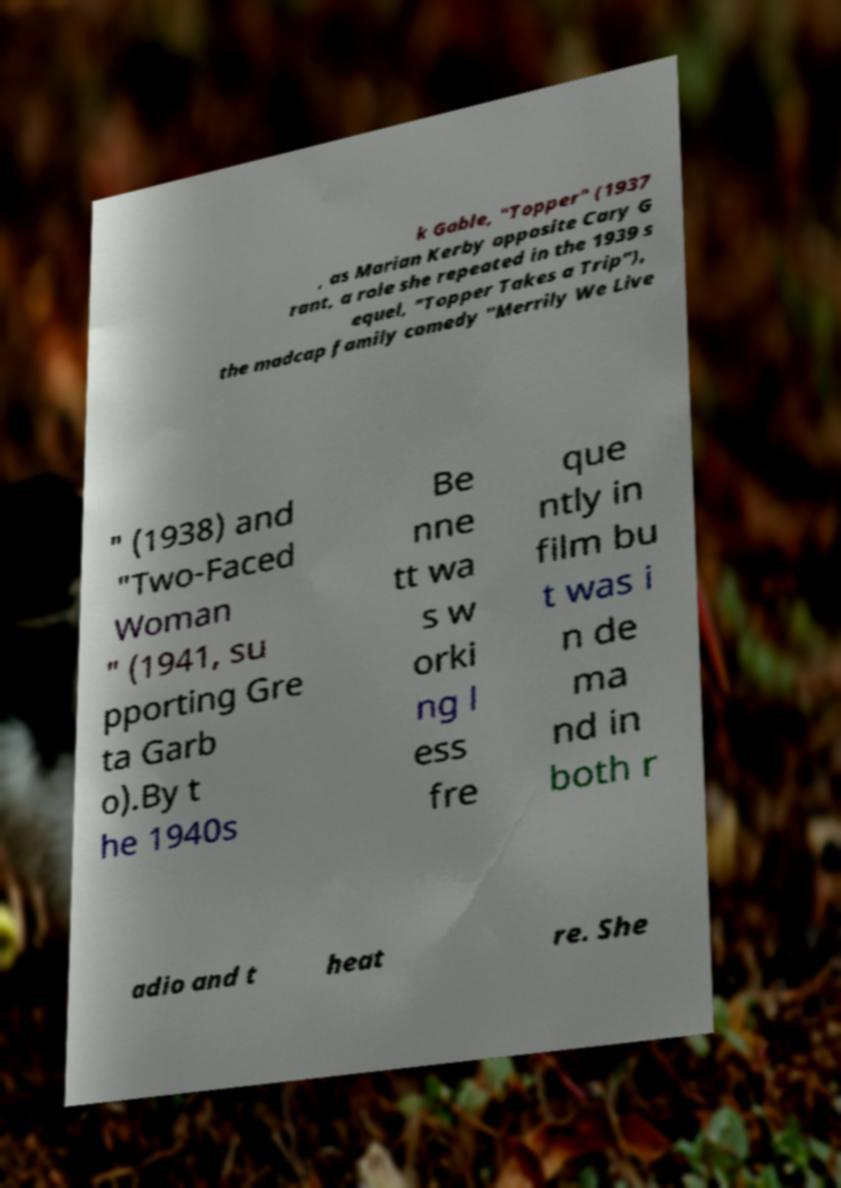There's text embedded in this image that I need extracted. Can you transcribe it verbatim? k Gable, "Topper" (1937 , as Marian Kerby opposite Cary G rant, a role she repeated in the 1939 s equel, "Topper Takes a Trip"), the madcap family comedy "Merrily We Live " (1938) and "Two-Faced Woman " (1941, su pporting Gre ta Garb o).By t he 1940s Be nne tt wa s w orki ng l ess fre que ntly in film bu t was i n de ma nd in both r adio and t heat re. She 